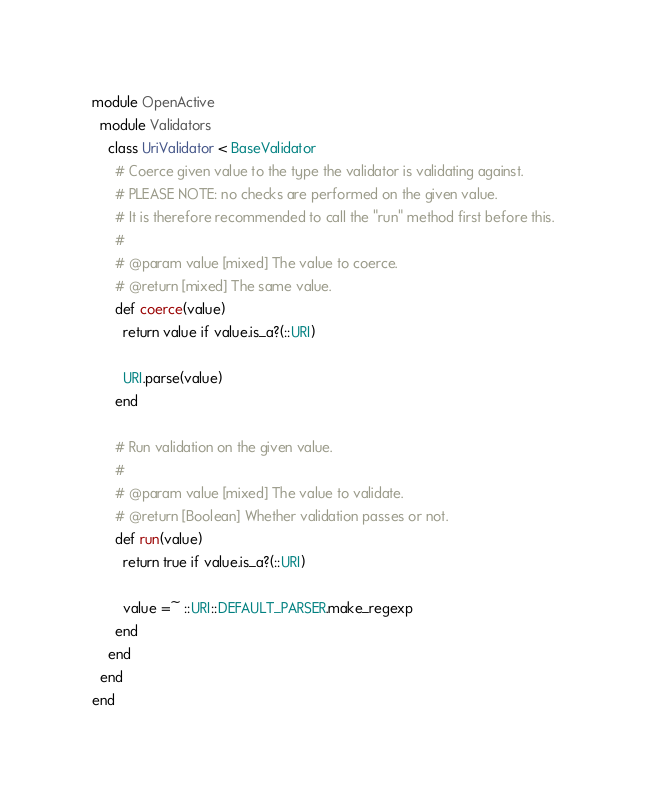Convert code to text. <code><loc_0><loc_0><loc_500><loc_500><_Ruby_>module OpenActive
  module Validators
    class UriValidator < BaseValidator
      # Coerce given value to the type the validator is validating against.
      # PLEASE NOTE: no checks are performed on the given value.
      # It is therefore recommended to call the "run" method first before this.
      #
      # @param value [mixed] The value to coerce.
      # @return [mixed] The same value.
      def coerce(value)
        return value if value.is_a?(::URI)

        URI.parse(value)
      end

      # Run validation on the given value.
      #
      # @param value [mixed] The value to validate.
      # @return [Boolean] Whether validation passes or not.
      def run(value)
        return true if value.is_a?(::URI)

        value =~ ::URI::DEFAULT_PARSER.make_regexp
      end
    end
  end
end
</code> 